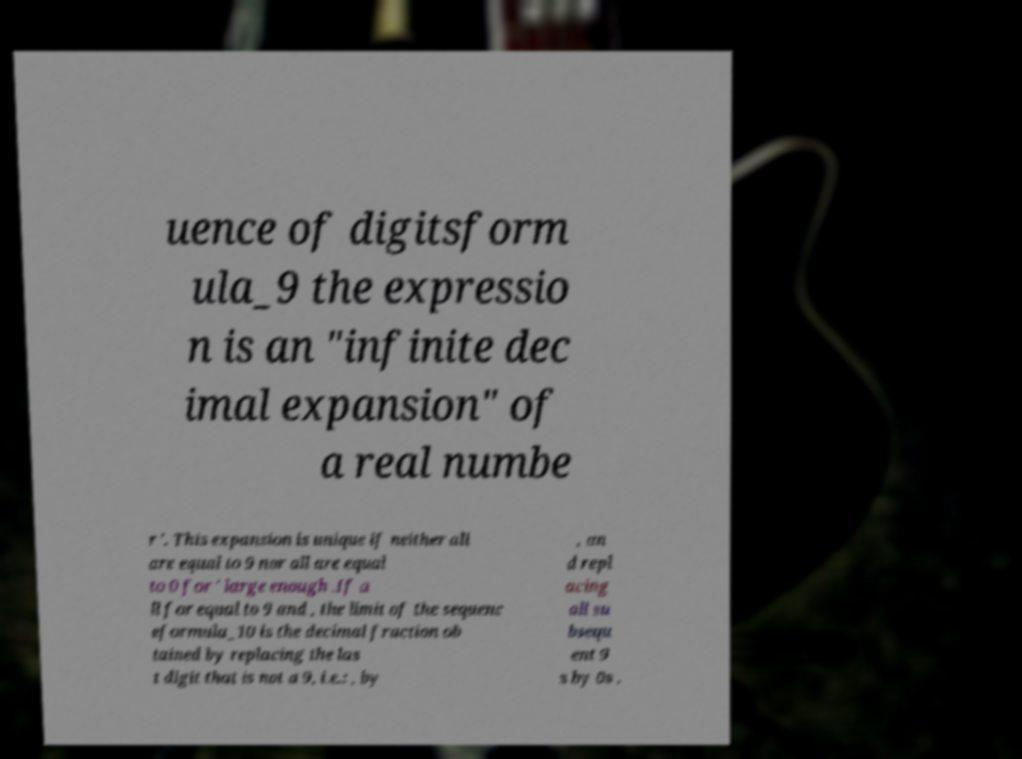Please read and relay the text visible in this image. What does it say? uence of digitsform ula_9 the expressio n is an "infinite dec imal expansion" of a real numbe r '. This expansion is unique if neither all are equal to 9 nor all are equal to 0 for ' large enough .If a ll for equal to 9 and , the limit of the sequenc eformula_10 is the decimal fraction ob tained by replacing the las t digit that is not a 9, i.e.: , by , an d repl acing all su bsequ ent 9 s by 0s . 